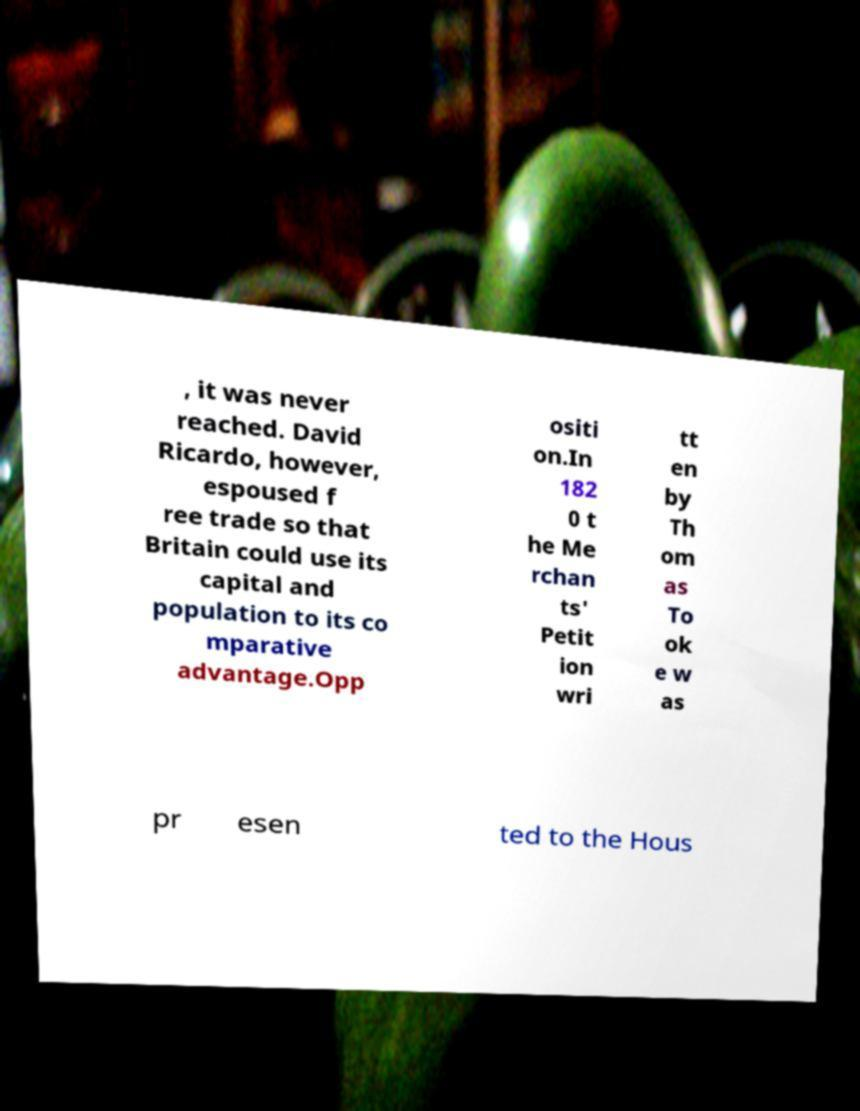I need the written content from this picture converted into text. Can you do that? , it was never reached. David Ricardo, however, espoused f ree trade so that Britain could use its capital and population to its co mparative advantage.Opp ositi on.In 182 0 t he Me rchan ts' Petit ion wri tt en by Th om as To ok e w as pr esen ted to the Hous 